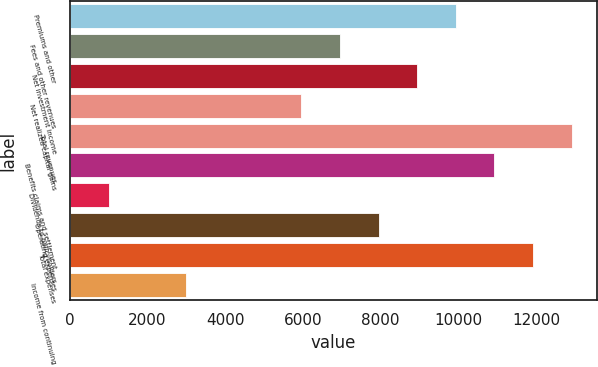Convert chart. <chart><loc_0><loc_0><loc_500><loc_500><bar_chart><fcel>Premiums and other<fcel>Fees and other revenues<fcel>Net investment income<fcel>Net realized capital gains<fcel>Total revenues<fcel>Benefits claims and settlement<fcel>Dividends to policyholders<fcel>Operating expenses<fcel>Total expenses<fcel>Income from continuing<nl><fcel>9935.9<fcel>6956.48<fcel>8942.76<fcel>5963.34<fcel>12915.3<fcel>10929<fcel>997.64<fcel>7949.62<fcel>11922.2<fcel>2983.92<nl></chart> 